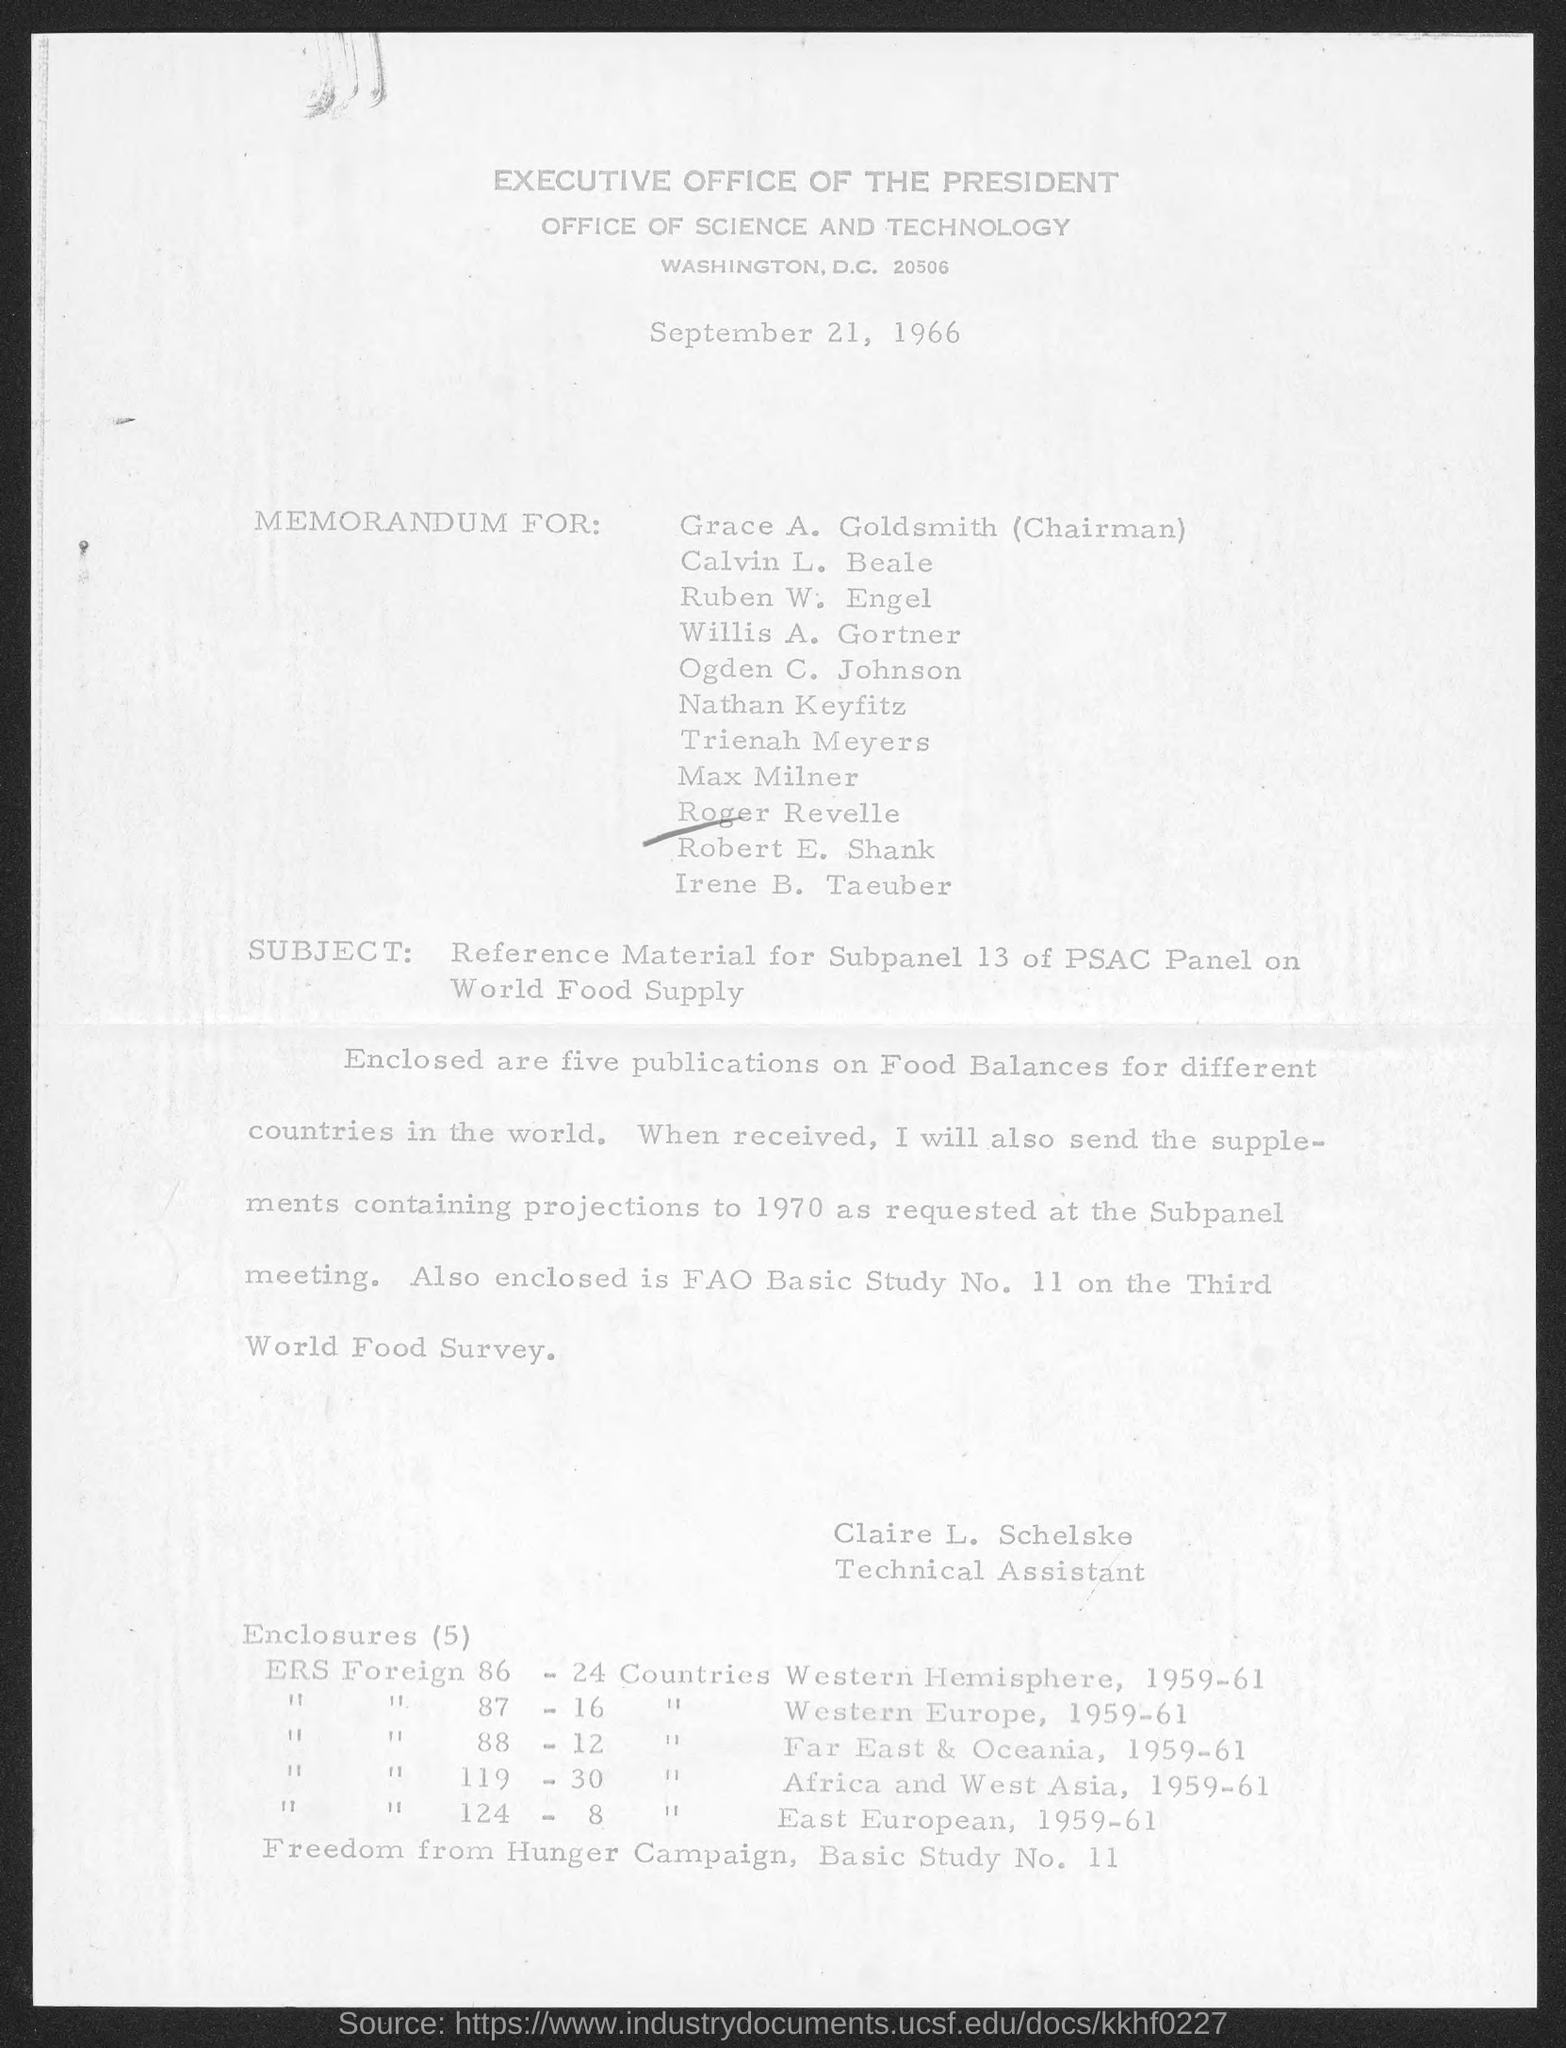When is the document dated?
Offer a very short reply. September 21, 1966. What is the subject of the document?
Keep it short and to the point. Reference Material for Subpanel 13 of PSAC Panel on World Food Supply. How many publications on Food Balances are enclosed?
Keep it short and to the point. Five. Who is the Technical Assistant?
Your response must be concise. Claire L. Schelske. 